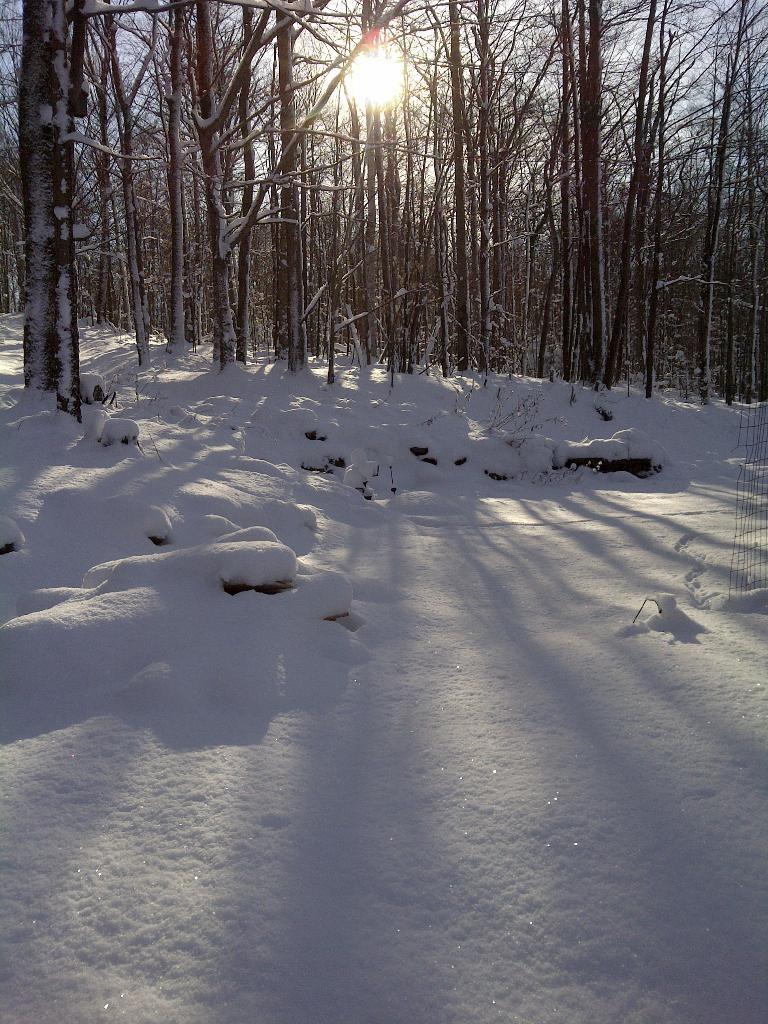Could you give a brief overview of what you see in this image? In this image we can see a group of trees, the sun and the sky. We can also see the ground covered with snow. 